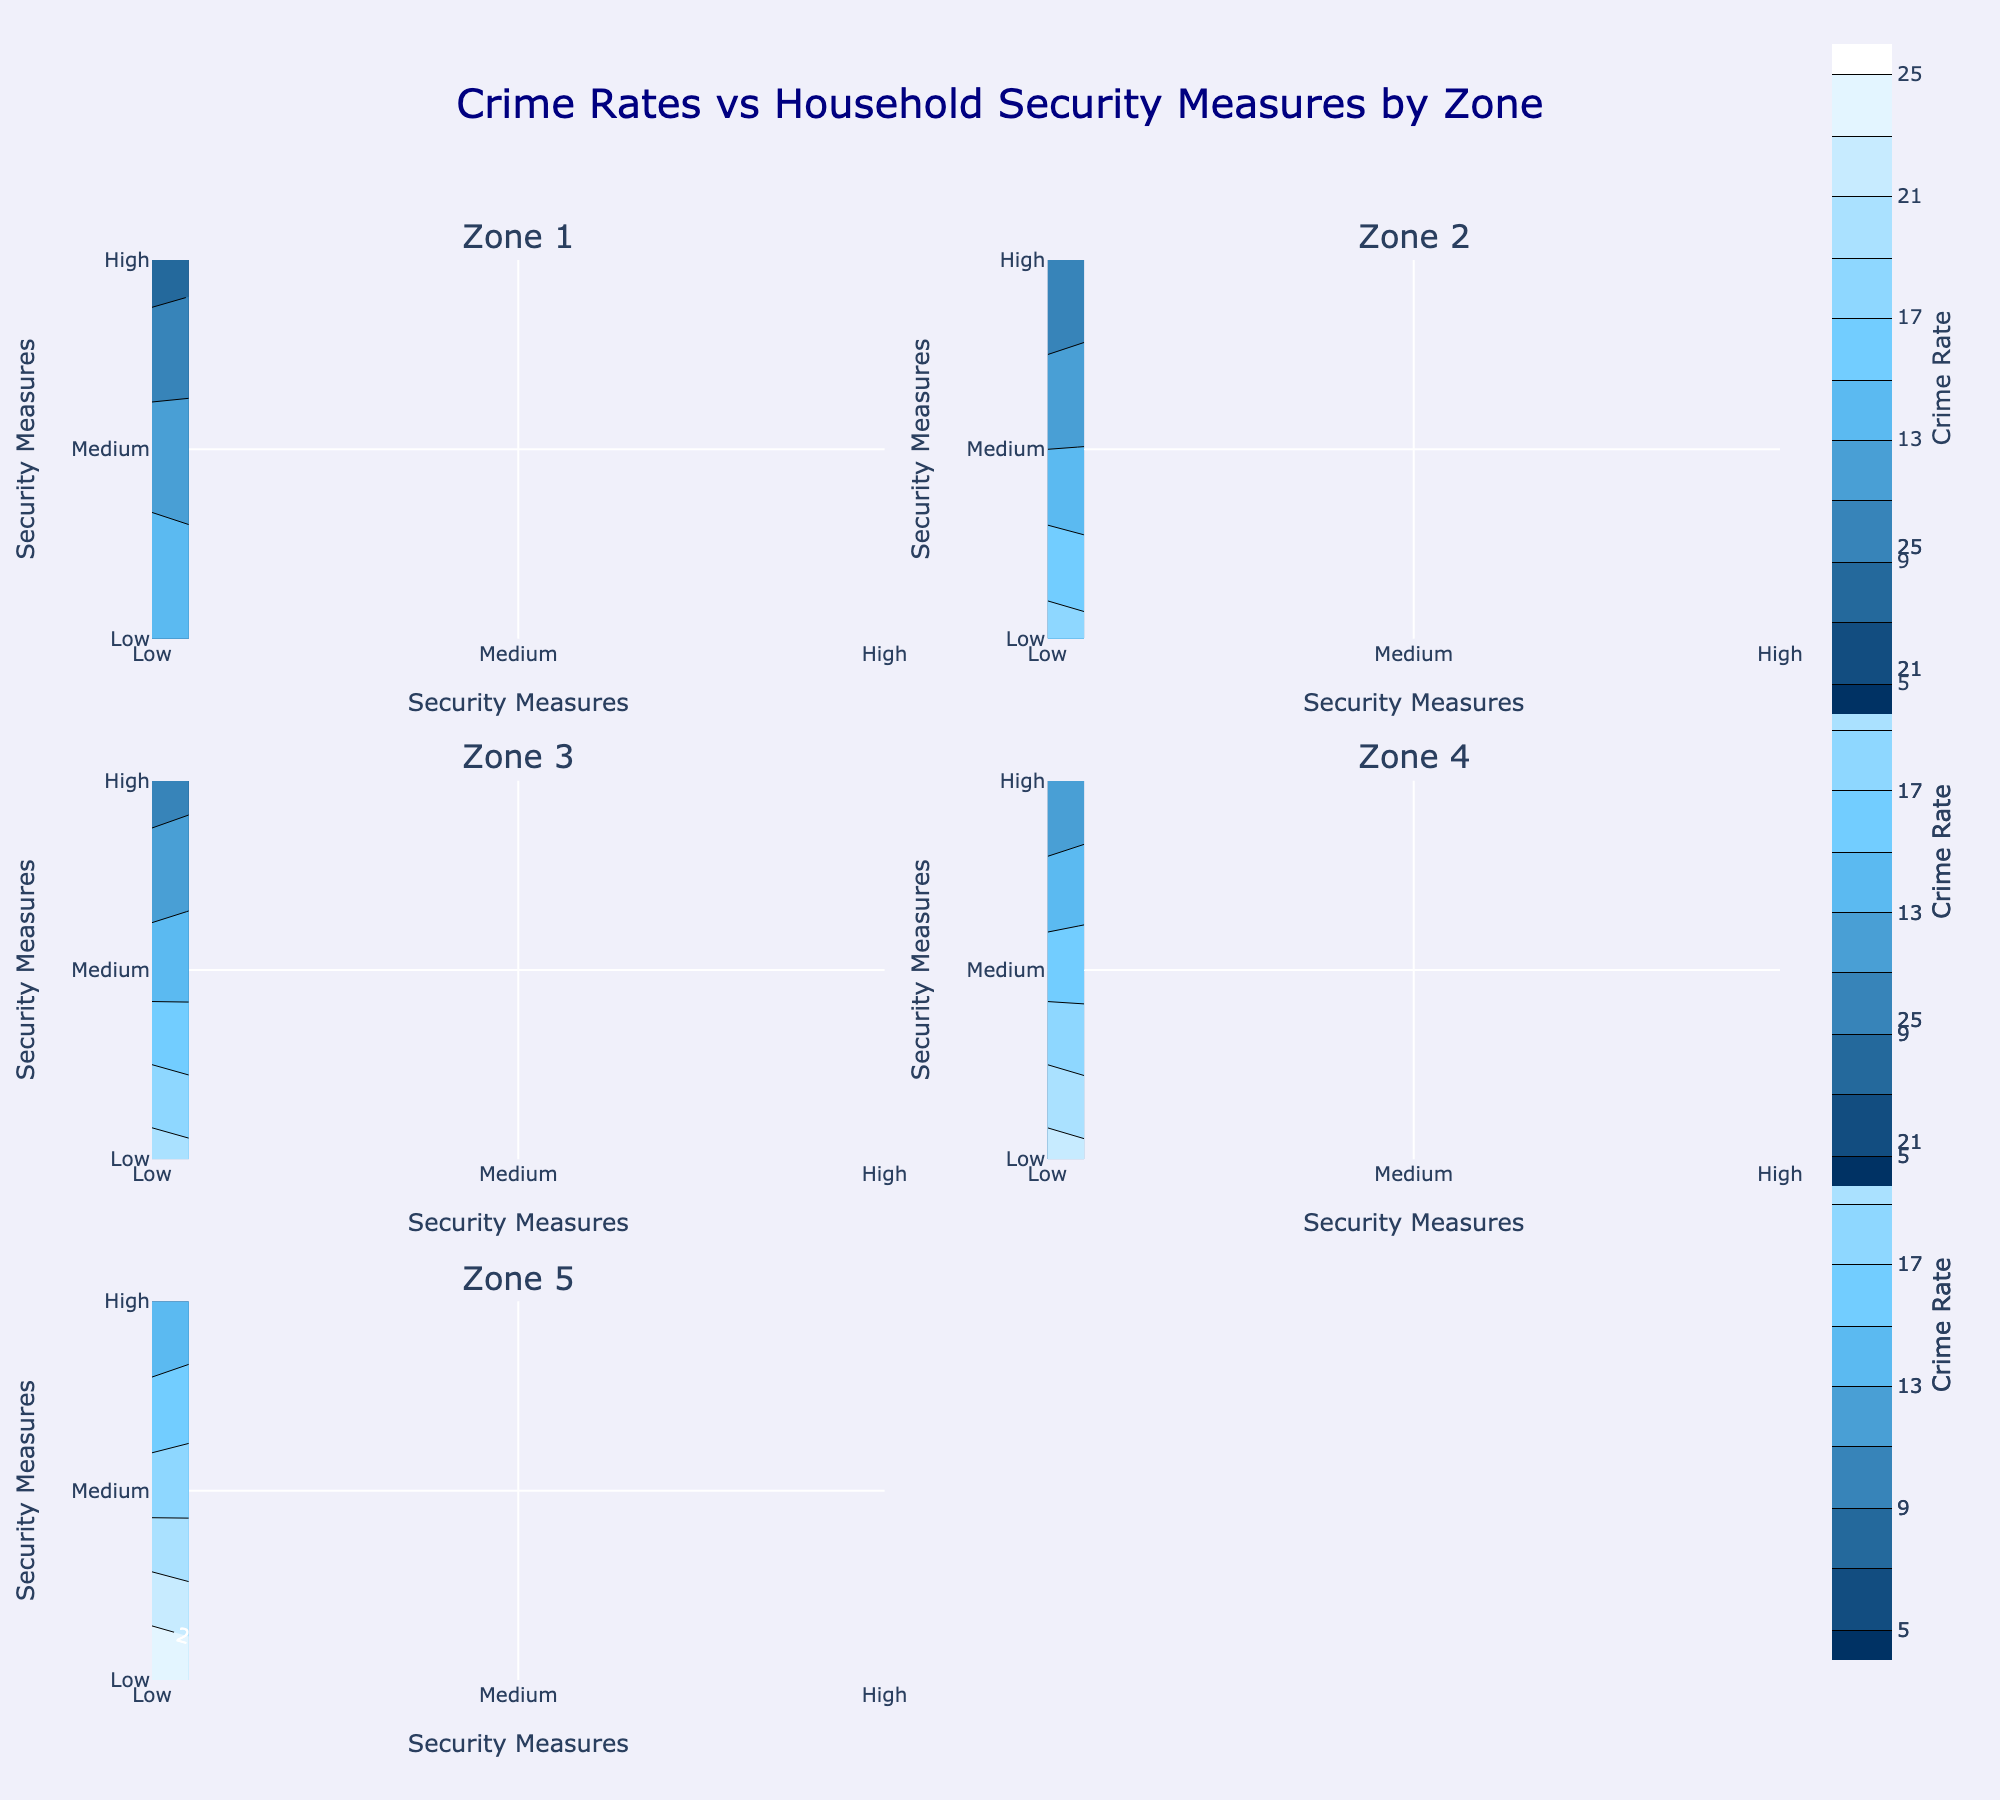what is the title of the figure? The title of the figure is displayed at the top center which states the purpose of the plot.
Answer: Crime Rates vs Household Security Measures by Zone What is the color associated with the highest crime rate? The colors associated with higher values on the contour plots are usually towards the lighter end of the color scale. From the custom color scale defined, light blue around 'rgb(100,200,255)' would be closer to the highest crime rate.
Answer: Light blue Which security measure level has the highest crime rate in Zone 3? By looking at the contour plot for Zone 3, the highest value corresponds to the 'Low' security measure, at the top left of the plot.
Answer: Low What is the trend of crime rates as security measures increase in Zone 1? Observing Zone 1's contour plot, the crime rates decrease as security measures improve from Low to High, going from 15 through 12 to 8.
Answer: Decreasing trend Compare the crime rates for 'Medium' security across all zones. Which zone has the highest crime rate? Checking each subplot for the crime rate at 'Medium' security, Zone 5 shows the highest crime rate of 18 compared to other zones.
Answer: Zone 5 What is the average crime rate for Zone 2? Adding up the crime rates for Zone 2 (18 + 13 + 9) gives 40. Dividing by 3 for the average yields approximately 13.33.
Answer: 13.33 Which zone shows the steepest decline in crime rate as security increases from Low to High? By assessing the differences, Zone 1 (15 to 12 to 8) shows a decline of 7, Zone 2 (18 to 13 to 9) shows a decline of 9, Zone 3 (20 to 14 to 10) shows a decline of 10, Zone 4 (22 to 16 to 11) shows a decline of 11, and Zone 5 (25 to 18 to 13) shows a decline of 12. Zone 5 has the steepest decline.
Answer: Zone 5 What is the minimum recorded crime rate across all zones and security levels? The crime rate values from all zones are 8, 9, 10, 11, and 13. The minimum value amongst them is 8, found in Zone 1 with a 'High' security measure.
Answer: 8 Is there any zone where crime rates don't decrease monotonically with increasing security measure levels? Each zone needs to be checked for any irregular increases. Zone 1 has values 15, 12, 8; Zone 2 has 18, 13, 9; Zone 3 has 20, 14, 10; Zone 4 has 22, 16, 11; Zone 5 has 25, 18, 13. All show a monotonic decrease.
Answer: No How many total unique zones and security measure levels are displayed in the figure? The figure shows 5 zones named Zone 1 through Zone 5, and 3 security measure levels: Low, Medium, and High.
Answer: 5 zones, 3 security measure levels 